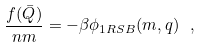Convert formula to latex. <formula><loc_0><loc_0><loc_500><loc_500>\frac { f ( \bar { Q } ) } { n m } = - \beta \phi _ { 1 R S B } ( m , q ) \ ,</formula> 